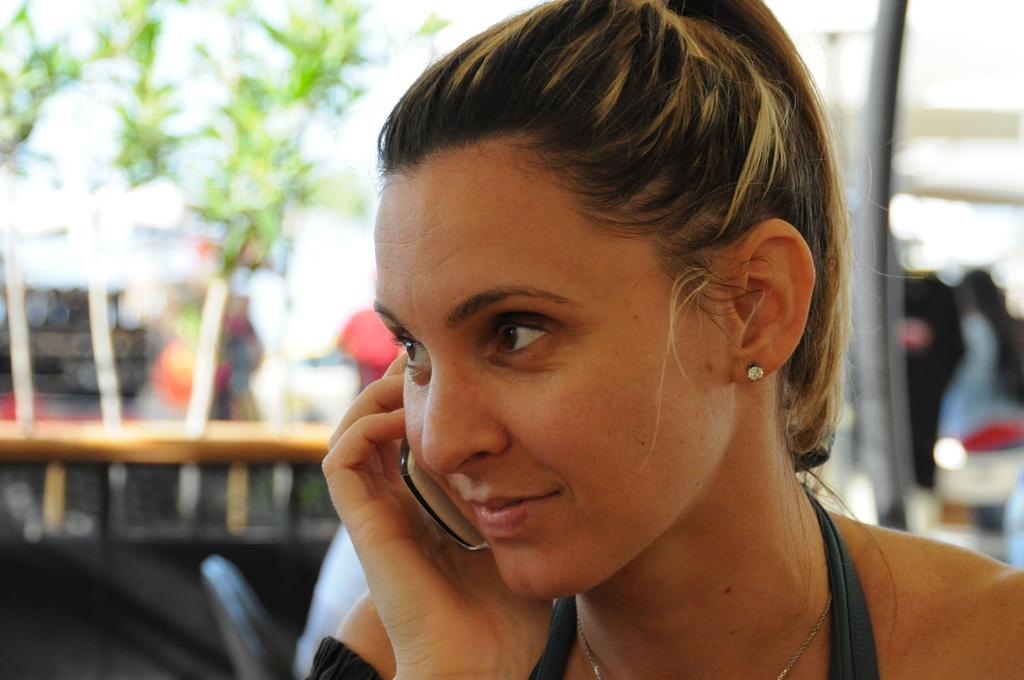Who is present in the image? There is a woman in the image. What is the woman holding in the image? The woman is holding a phone. How is the woman using the phone? The woman is keeping the phone near to her ear. What type of tax is being discussed on the phone call in the image? There is no indication in the image that the woman is discussing any type of tax on the phone call. 